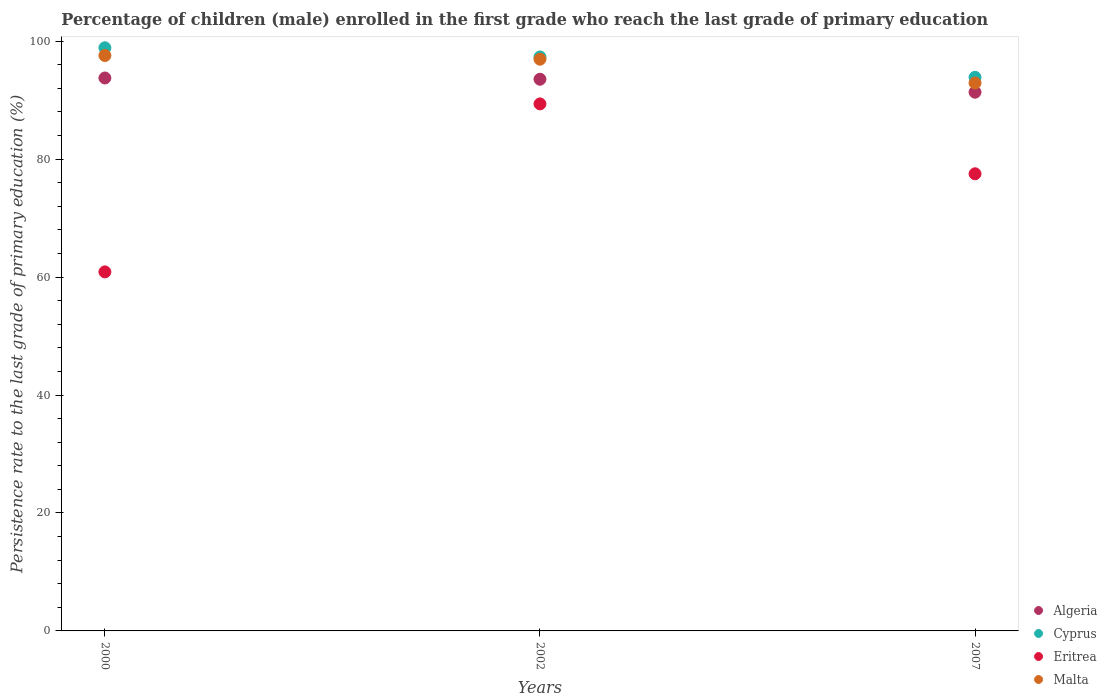How many different coloured dotlines are there?
Give a very brief answer. 4. What is the persistence rate of children in Algeria in 2007?
Your response must be concise. 91.34. Across all years, what is the maximum persistence rate of children in Eritrea?
Provide a short and direct response. 89.36. Across all years, what is the minimum persistence rate of children in Cyprus?
Your answer should be very brief. 93.87. In which year was the persistence rate of children in Algeria maximum?
Offer a terse response. 2000. What is the total persistence rate of children in Algeria in the graph?
Offer a terse response. 278.64. What is the difference between the persistence rate of children in Cyprus in 2000 and that in 2007?
Ensure brevity in your answer.  5.01. What is the difference between the persistence rate of children in Malta in 2002 and the persistence rate of children in Eritrea in 2007?
Provide a succinct answer. 19.43. What is the average persistence rate of children in Algeria per year?
Give a very brief answer. 92.88. In the year 2007, what is the difference between the persistence rate of children in Malta and persistence rate of children in Algeria?
Make the answer very short. 1.56. What is the ratio of the persistence rate of children in Malta in 2000 to that in 2002?
Ensure brevity in your answer.  1.01. Is the persistence rate of children in Cyprus in 2000 less than that in 2007?
Provide a succinct answer. No. Is the difference between the persistence rate of children in Malta in 2000 and 2002 greater than the difference between the persistence rate of children in Algeria in 2000 and 2002?
Keep it short and to the point. Yes. What is the difference between the highest and the second highest persistence rate of children in Algeria?
Offer a terse response. 0.21. What is the difference between the highest and the lowest persistence rate of children in Malta?
Provide a succinct answer. 4.66. In how many years, is the persistence rate of children in Cyprus greater than the average persistence rate of children in Cyprus taken over all years?
Provide a short and direct response. 2. Is it the case that in every year, the sum of the persistence rate of children in Eritrea and persistence rate of children in Malta  is greater than the sum of persistence rate of children in Cyprus and persistence rate of children in Algeria?
Provide a short and direct response. No. Is the persistence rate of children in Eritrea strictly greater than the persistence rate of children in Cyprus over the years?
Your response must be concise. No. How many years are there in the graph?
Give a very brief answer. 3. What is the difference between two consecutive major ticks on the Y-axis?
Keep it short and to the point. 20. Does the graph contain any zero values?
Make the answer very short. No. Where does the legend appear in the graph?
Give a very brief answer. Bottom right. How many legend labels are there?
Give a very brief answer. 4. How are the legend labels stacked?
Ensure brevity in your answer.  Vertical. What is the title of the graph?
Give a very brief answer. Percentage of children (male) enrolled in the first grade who reach the last grade of primary education. Does "Ethiopia" appear as one of the legend labels in the graph?
Offer a terse response. No. What is the label or title of the Y-axis?
Ensure brevity in your answer.  Persistence rate to the last grade of primary education (%). What is the Persistence rate to the last grade of primary education (%) in Algeria in 2000?
Offer a very short reply. 93.75. What is the Persistence rate to the last grade of primary education (%) in Cyprus in 2000?
Make the answer very short. 98.88. What is the Persistence rate to the last grade of primary education (%) in Eritrea in 2000?
Your answer should be compact. 60.88. What is the Persistence rate to the last grade of primary education (%) in Malta in 2000?
Offer a very short reply. 97.57. What is the Persistence rate to the last grade of primary education (%) in Algeria in 2002?
Your response must be concise. 93.54. What is the Persistence rate to the last grade of primary education (%) in Cyprus in 2002?
Your answer should be very brief. 97.32. What is the Persistence rate to the last grade of primary education (%) of Eritrea in 2002?
Your response must be concise. 89.36. What is the Persistence rate to the last grade of primary education (%) in Malta in 2002?
Provide a succinct answer. 96.94. What is the Persistence rate to the last grade of primary education (%) in Algeria in 2007?
Offer a terse response. 91.34. What is the Persistence rate to the last grade of primary education (%) in Cyprus in 2007?
Your answer should be compact. 93.87. What is the Persistence rate to the last grade of primary education (%) in Eritrea in 2007?
Provide a short and direct response. 77.51. What is the Persistence rate to the last grade of primary education (%) in Malta in 2007?
Make the answer very short. 92.9. Across all years, what is the maximum Persistence rate to the last grade of primary education (%) of Algeria?
Provide a succinct answer. 93.75. Across all years, what is the maximum Persistence rate to the last grade of primary education (%) in Cyprus?
Your answer should be very brief. 98.88. Across all years, what is the maximum Persistence rate to the last grade of primary education (%) in Eritrea?
Make the answer very short. 89.36. Across all years, what is the maximum Persistence rate to the last grade of primary education (%) in Malta?
Your answer should be compact. 97.57. Across all years, what is the minimum Persistence rate to the last grade of primary education (%) in Algeria?
Your answer should be compact. 91.34. Across all years, what is the minimum Persistence rate to the last grade of primary education (%) of Cyprus?
Ensure brevity in your answer.  93.87. Across all years, what is the minimum Persistence rate to the last grade of primary education (%) of Eritrea?
Your response must be concise. 60.88. Across all years, what is the minimum Persistence rate to the last grade of primary education (%) of Malta?
Give a very brief answer. 92.9. What is the total Persistence rate to the last grade of primary education (%) in Algeria in the graph?
Make the answer very short. 278.64. What is the total Persistence rate to the last grade of primary education (%) in Cyprus in the graph?
Offer a terse response. 290.06. What is the total Persistence rate to the last grade of primary education (%) of Eritrea in the graph?
Your response must be concise. 227.75. What is the total Persistence rate to the last grade of primary education (%) in Malta in the graph?
Offer a very short reply. 287.41. What is the difference between the Persistence rate to the last grade of primary education (%) of Algeria in 2000 and that in 2002?
Provide a short and direct response. 0.21. What is the difference between the Persistence rate to the last grade of primary education (%) of Cyprus in 2000 and that in 2002?
Ensure brevity in your answer.  1.55. What is the difference between the Persistence rate to the last grade of primary education (%) in Eritrea in 2000 and that in 2002?
Ensure brevity in your answer.  -28.49. What is the difference between the Persistence rate to the last grade of primary education (%) in Malta in 2000 and that in 2002?
Keep it short and to the point. 0.63. What is the difference between the Persistence rate to the last grade of primary education (%) in Algeria in 2000 and that in 2007?
Provide a succinct answer. 2.41. What is the difference between the Persistence rate to the last grade of primary education (%) of Cyprus in 2000 and that in 2007?
Provide a short and direct response. 5.01. What is the difference between the Persistence rate to the last grade of primary education (%) of Eritrea in 2000 and that in 2007?
Your answer should be very brief. -16.63. What is the difference between the Persistence rate to the last grade of primary education (%) of Malta in 2000 and that in 2007?
Give a very brief answer. 4.66. What is the difference between the Persistence rate to the last grade of primary education (%) of Algeria in 2002 and that in 2007?
Provide a short and direct response. 2.2. What is the difference between the Persistence rate to the last grade of primary education (%) of Cyprus in 2002 and that in 2007?
Offer a very short reply. 3.45. What is the difference between the Persistence rate to the last grade of primary education (%) in Eritrea in 2002 and that in 2007?
Ensure brevity in your answer.  11.85. What is the difference between the Persistence rate to the last grade of primary education (%) in Malta in 2002 and that in 2007?
Give a very brief answer. 4.04. What is the difference between the Persistence rate to the last grade of primary education (%) of Algeria in 2000 and the Persistence rate to the last grade of primary education (%) of Cyprus in 2002?
Provide a succinct answer. -3.57. What is the difference between the Persistence rate to the last grade of primary education (%) in Algeria in 2000 and the Persistence rate to the last grade of primary education (%) in Eritrea in 2002?
Your answer should be compact. 4.39. What is the difference between the Persistence rate to the last grade of primary education (%) of Algeria in 2000 and the Persistence rate to the last grade of primary education (%) of Malta in 2002?
Your response must be concise. -3.19. What is the difference between the Persistence rate to the last grade of primary education (%) of Cyprus in 2000 and the Persistence rate to the last grade of primary education (%) of Eritrea in 2002?
Offer a very short reply. 9.51. What is the difference between the Persistence rate to the last grade of primary education (%) of Cyprus in 2000 and the Persistence rate to the last grade of primary education (%) of Malta in 2002?
Provide a short and direct response. 1.94. What is the difference between the Persistence rate to the last grade of primary education (%) in Eritrea in 2000 and the Persistence rate to the last grade of primary education (%) in Malta in 2002?
Provide a succinct answer. -36.06. What is the difference between the Persistence rate to the last grade of primary education (%) in Algeria in 2000 and the Persistence rate to the last grade of primary education (%) in Cyprus in 2007?
Keep it short and to the point. -0.11. What is the difference between the Persistence rate to the last grade of primary education (%) of Algeria in 2000 and the Persistence rate to the last grade of primary education (%) of Eritrea in 2007?
Provide a short and direct response. 16.24. What is the difference between the Persistence rate to the last grade of primary education (%) of Algeria in 2000 and the Persistence rate to the last grade of primary education (%) of Malta in 2007?
Provide a succinct answer. 0.85. What is the difference between the Persistence rate to the last grade of primary education (%) in Cyprus in 2000 and the Persistence rate to the last grade of primary education (%) in Eritrea in 2007?
Your response must be concise. 21.37. What is the difference between the Persistence rate to the last grade of primary education (%) in Cyprus in 2000 and the Persistence rate to the last grade of primary education (%) in Malta in 2007?
Ensure brevity in your answer.  5.97. What is the difference between the Persistence rate to the last grade of primary education (%) in Eritrea in 2000 and the Persistence rate to the last grade of primary education (%) in Malta in 2007?
Provide a short and direct response. -32.03. What is the difference between the Persistence rate to the last grade of primary education (%) in Algeria in 2002 and the Persistence rate to the last grade of primary education (%) in Cyprus in 2007?
Your response must be concise. -0.33. What is the difference between the Persistence rate to the last grade of primary education (%) of Algeria in 2002 and the Persistence rate to the last grade of primary education (%) of Eritrea in 2007?
Provide a succinct answer. 16.03. What is the difference between the Persistence rate to the last grade of primary education (%) of Algeria in 2002 and the Persistence rate to the last grade of primary education (%) of Malta in 2007?
Your answer should be very brief. 0.64. What is the difference between the Persistence rate to the last grade of primary education (%) of Cyprus in 2002 and the Persistence rate to the last grade of primary education (%) of Eritrea in 2007?
Make the answer very short. 19.81. What is the difference between the Persistence rate to the last grade of primary education (%) in Cyprus in 2002 and the Persistence rate to the last grade of primary education (%) in Malta in 2007?
Offer a very short reply. 4.42. What is the difference between the Persistence rate to the last grade of primary education (%) in Eritrea in 2002 and the Persistence rate to the last grade of primary education (%) in Malta in 2007?
Make the answer very short. -3.54. What is the average Persistence rate to the last grade of primary education (%) of Algeria per year?
Offer a terse response. 92.88. What is the average Persistence rate to the last grade of primary education (%) in Cyprus per year?
Your answer should be compact. 96.69. What is the average Persistence rate to the last grade of primary education (%) in Eritrea per year?
Make the answer very short. 75.92. What is the average Persistence rate to the last grade of primary education (%) of Malta per year?
Your answer should be very brief. 95.8. In the year 2000, what is the difference between the Persistence rate to the last grade of primary education (%) in Algeria and Persistence rate to the last grade of primary education (%) in Cyprus?
Give a very brief answer. -5.12. In the year 2000, what is the difference between the Persistence rate to the last grade of primary education (%) in Algeria and Persistence rate to the last grade of primary education (%) in Eritrea?
Offer a very short reply. 32.88. In the year 2000, what is the difference between the Persistence rate to the last grade of primary education (%) of Algeria and Persistence rate to the last grade of primary education (%) of Malta?
Provide a succinct answer. -3.81. In the year 2000, what is the difference between the Persistence rate to the last grade of primary education (%) of Cyprus and Persistence rate to the last grade of primary education (%) of Eritrea?
Your answer should be compact. 38. In the year 2000, what is the difference between the Persistence rate to the last grade of primary education (%) in Cyprus and Persistence rate to the last grade of primary education (%) in Malta?
Give a very brief answer. 1.31. In the year 2000, what is the difference between the Persistence rate to the last grade of primary education (%) in Eritrea and Persistence rate to the last grade of primary education (%) in Malta?
Provide a short and direct response. -36.69. In the year 2002, what is the difference between the Persistence rate to the last grade of primary education (%) of Algeria and Persistence rate to the last grade of primary education (%) of Cyprus?
Provide a succinct answer. -3.78. In the year 2002, what is the difference between the Persistence rate to the last grade of primary education (%) of Algeria and Persistence rate to the last grade of primary education (%) of Eritrea?
Give a very brief answer. 4.18. In the year 2002, what is the difference between the Persistence rate to the last grade of primary education (%) in Algeria and Persistence rate to the last grade of primary education (%) in Malta?
Offer a very short reply. -3.4. In the year 2002, what is the difference between the Persistence rate to the last grade of primary education (%) in Cyprus and Persistence rate to the last grade of primary education (%) in Eritrea?
Your answer should be compact. 7.96. In the year 2002, what is the difference between the Persistence rate to the last grade of primary education (%) in Cyprus and Persistence rate to the last grade of primary education (%) in Malta?
Your answer should be very brief. 0.38. In the year 2002, what is the difference between the Persistence rate to the last grade of primary education (%) of Eritrea and Persistence rate to the last grade of primary education (%) of Malta?
Your answer should be compact. -7.58. In the year 2007, what is the difference between the Persistence rate to the last grade of primary education (%) in Algeria and Persistence rate to the last grade of primary education (%) in Cyprus?
Offer a very short reply. -2.52. In the year 2007, what is the difference between the Persistence rate to the last grade of primary education (%) of Algeria and Persistence rate to the last grade of primary education (%) of Eritrea?
Your response must be concise. 13.83. In the year 2007, what is the difference between the Persistence rate to the last grade of primary education (%) in Algeria and Persistence rate to the last grade of primary education (%) in Malta?
Your response must be concise. -1.56. In the year 2007, what is the difference between the Persistence rate to the last grade of primary education (%) of Cyprus and Persistence rate to the last grade of primary education (%) of Eritrea?
Provide a succinct answer. 16.36. In the year 2007, what is the difference between the Persistence rate to the last grade of primary education (%) in Eritrea and Persistence rate to the last grade of primary education (%) in Malta?
Offer a very short reply. -15.39. What is the ratio of the Persistence rate to the last grade of primary education (%) of Algeria in 2000 to that in 2002?
Your answer should be very brief. 1. What is the ratio of the Persistence rate to the last grade of primary education (%) of Eritrea in 2000 to that in 2002?
Make the answer very short. 0.68. What is the ratio of the Persistence rate to the last grade of primary education (%) in Malta in 2000 to that in 2002?
Offer a very short reply. 1.01. What is the ratio of the Persistence rate to the last grade of primary education (%) in Algeria in 2000 to that in 2007?
Make the answer very short. 1.03. What is the ratio of the Persistence rate to the last grade of primary education (%) in Cyprus in 2000 to that in 2007?
Your answer should be very brief. 1.05. What is the ratio of the Persistence rate to the last grade of primary education (%) in Eritrea in 2000 to that in 2007?
Provide a succinct answer. 0.79. What is the ratio of the Persistence rate to the last grade of primary education (%) of Malta in 2000 to that in 2007?
Your response must be concise. 1.05. What is the ratio of the Persistence rate to the last grade of primary education (%) in Algeria in 2002 to that in 2007?
Ensure brevity in your answer.  1.02. What is the ratio of the Persistence rate to the last grade of primary education (%) in Cyprus in 2002 to that in 2007?
Provide a short and direct response. 1.04. What is the ratio of the Persistence rate to the last grade of primary education (%) in Eritrea in 2002 to that in 2007?
Give a very brief answer. 1.15. What is the ratio of the Persistence rate to the last grade of primary education (%) in Malta in 2002 to that in 2007?
Offer a terse response. 1.04. What is the difference between the highest and the second highest Persistence rate to the last grade of primary education (%) of Algeria?
Provide a succinct answer. 0.21. What is the difference between the highest and the second highest Persistence rate to the last grade of primary education (%) of Cyprus?
Offer a terse response. 1.55. What is the difference between the highest and the second highest Persistence rate to the last grade of primary education (%) in Eritrea?
Your response must be concise. 11.85. What is the difference between the highest and the second highest Persistence rate to the last grade of primary education (%) of Malta?
Give a very brief answer. 0.63. What is the difference between the highest and the lowest Persistence rate to the last grade of primary education (%) of Algeria?
Your answer should be compact. 2.41. What is the difference between the highest and the lowest Persistence rate to the last grade of primary education (%) in Cyprus?
Your answer should be compact. 5.01. What is the difference between the highest and the lowest Persistence rate to the last grade of primary education (%) of Eritrea?
Provide a succinct answer. 28.49. What is the difference between the highest and the lowest Persistence rate to the last grade of primary education (%) in Malta?
Your response must be concise. 4.66. 